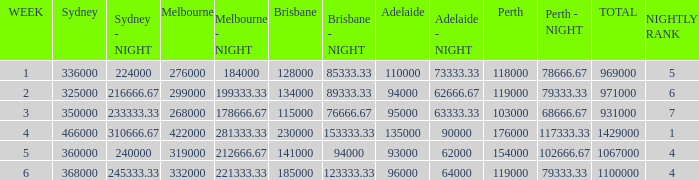What was the rating for Brisbane the week that Adelaide had 94000? 134000.0. I'm looking to parse the entire table for insights. Could you assist me with that? {'header': ['WEEK', 'Sydney', 'Sydney - NIGHT', 'Melbourne', 'Melbourne - NIGHT', 'Brisbane', 'Brisbane - NIGHT', 'Adelaide', 'Adelaide - NIGHT', 'Perth', 'Perth - NIGHT', 'TOTAL', 'NIGHTLY RANK'], 'rows': [['1', '336000', '224000', '276000', '184000', '128000', '85333.33', '110000', '73333.33', '118000', '78666.67', '969000', '5'], ['2', '325000', '216666.67', '299000', '199333.33', '134000', '89333.33', '94000', '62666.67', '119000', '79333.33', '971000', '6'], ['3', '350000', '233333.33', '268000', '178666.67', '115000', '76666.67', '95000', '63333.33', '103000', '68666.67', '931000', '7'], ['4', '466000', '310666.67', '422000', '281333.33', '230000', '153333.33', '135000', '90000', '176000', '117333.33', '1429000', '1'], ['5', '360000', '240000', '319000', '212666.67', '141000', '94000', '93000', '62000', '154000', '102666.67', '1067000', '4'], ['6', '368000', '245333.33', '332000', '221333.33', '185000', '123333.33', '96000', '64000', '119000', '79333.33', '1100000', '4']]} 